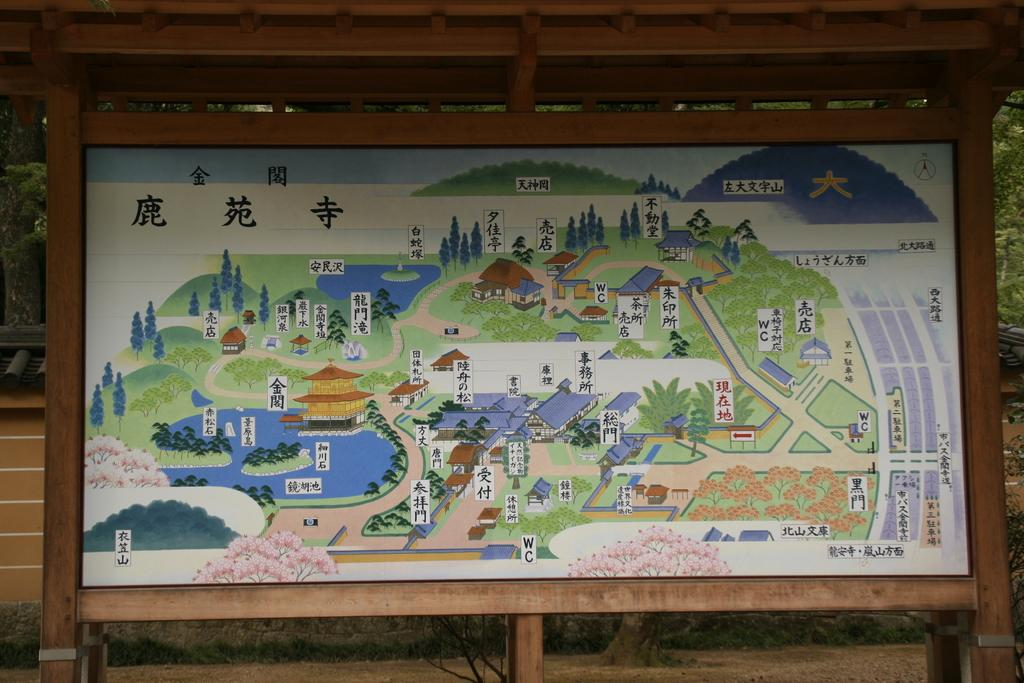What is the main subject of the image? The main subject of the image is a photo of a map. How many ladybugs can be seen on the map in the image? There are no ladybugs present in the image; it features a photo of a map. What type of school is depicted in the image? There is no school depicted in the image; it features a photo of a map. 